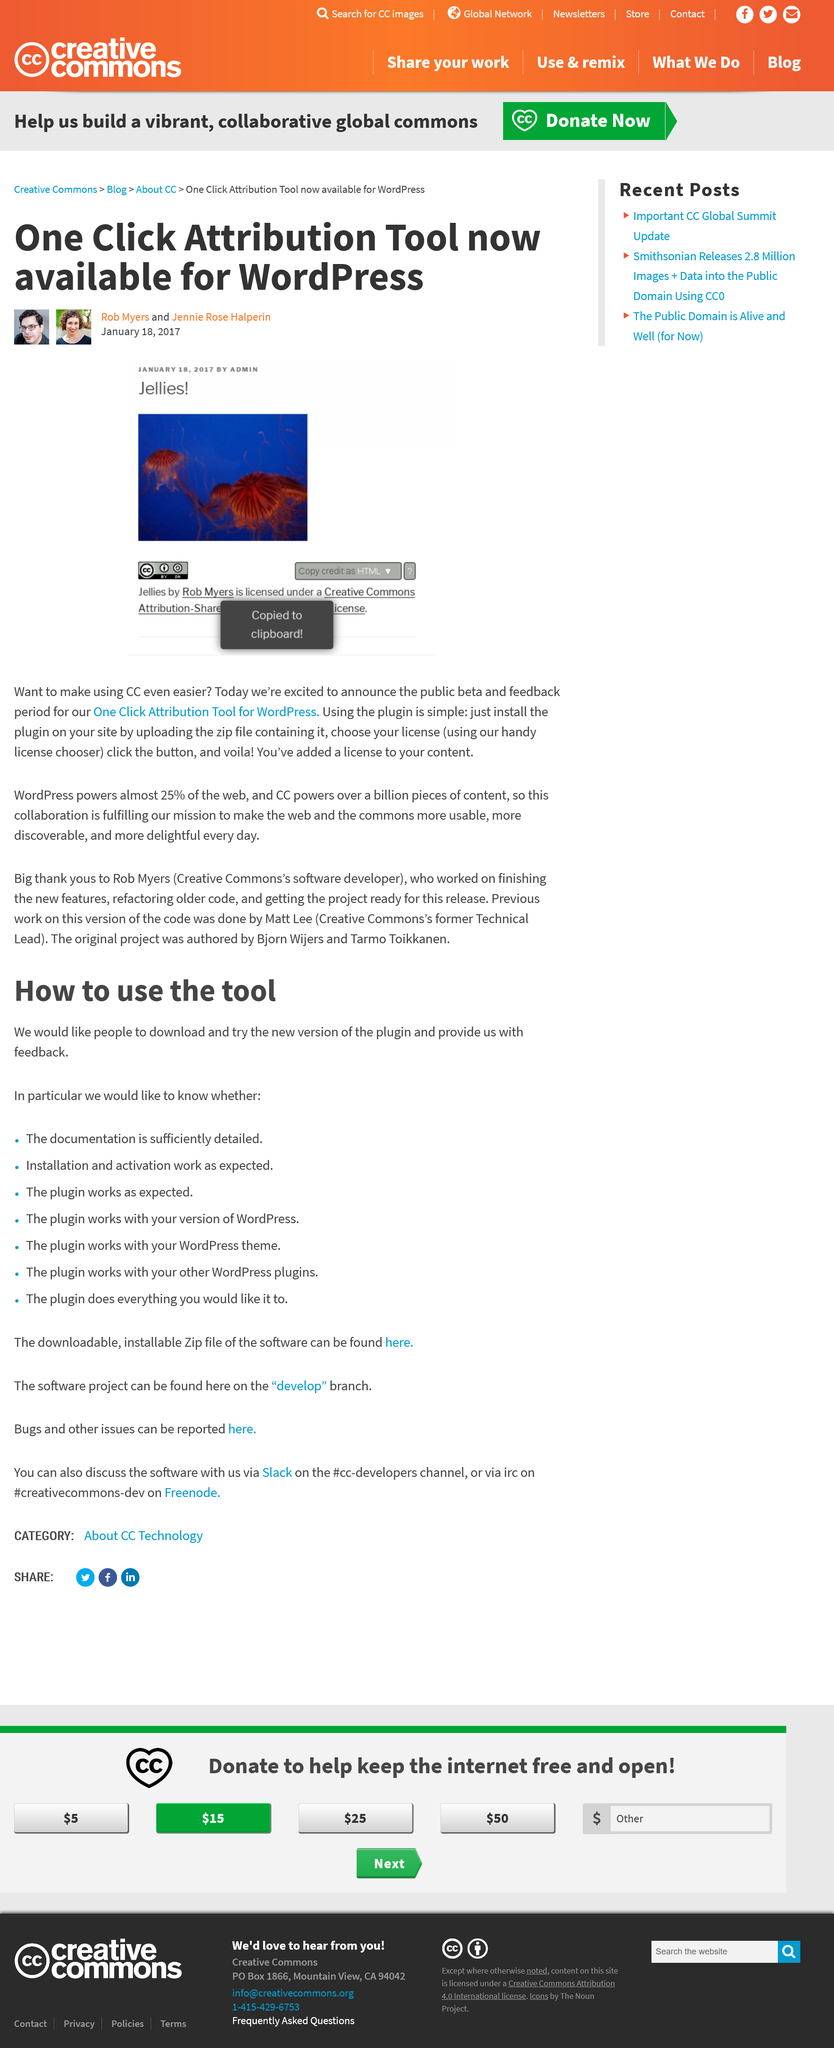List a handful of essential elements in this visual. The image of a creature is a jelly. The article was written on January 18, 2017. Now available for WordPress is the One Click Attribution Tool, which is a tool that allows for easy attribution. 